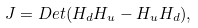Convert formula to latex. <formula><loc_0><loc_0><loc_500><loc_500>J = D e t ( H _ { d } H _ { u } - H _ { u } H _ { d } ) ,</formula> 